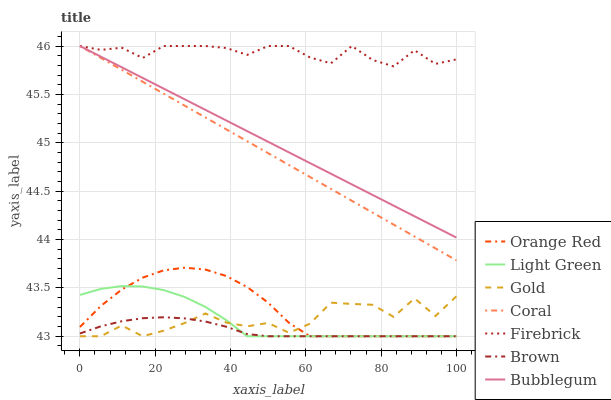Does Brown have the minimum area under the curve?
Answer yes or no. Yes. Does Firebrick have the maximum area under the curve?
Answer yes or no. Yes. Does Gold have the minimum area under the curve?
Answer yes or no. No. Does Gold have the maximum area under the curve?
Answer yes or no. No. Is Bubblegum the smoothest?
Answer yes or no. Yes. Is Gold the roughest?
Answer yes or no. Yes. Is Coral the smoothest?
Answer yes or no. No. Is Coral the roughest?
Answer yes or no. No. Does Brown have the lowest value?
Answer yes or no. Yes. Does Coral have the lowest value?
Answer yes or no. No. Does Firebrick have the highest value?
Answer yes or no. Yes. Does Gold have the highest value?
Answer yes or no. No. Is Gold less than Coral?
Answer yes or no. Yes. Is Firebrick greater than Light Green?
Answer yes or no. Yes. Does Bubblegum intersect Coral?
Answer yes or no. Yes. Is Bubblegum less than Coral?
Answer yes or no. No. Is Bubblegum greater than Coral?
Answer yes or no. No. Does Gold intersect Coral?
Answer yes or no. No. 